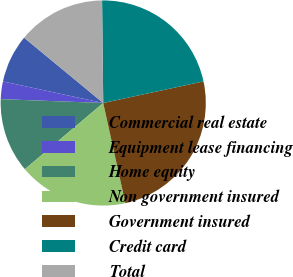Convert chart to OTSL. <chart><loc_0><loc_0><loc_500><loc_500><pie_chart><fcel>Commercial real estate<fcel>Equipment lease financing<fcel>Home equity<fcel>Non government insured<fcel>Government insured<fcel>Credit card<fcel>Total<nl><fcel>7.61%<fcel>2.77%<fcel>11.76%<fcel>17.3%<fcel>24.91%<fcel>21.8%<fcel>13.84%<nl></chart> 